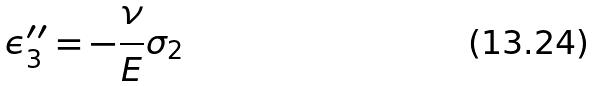Convert formula to latex. <formula><loc_0><loc_0><loc_500><loc_500>\epsilon _ { 3 } ^ { \prime \prime } = - \frac { \nu } { E } \sigma _ { 2 }</formula> 